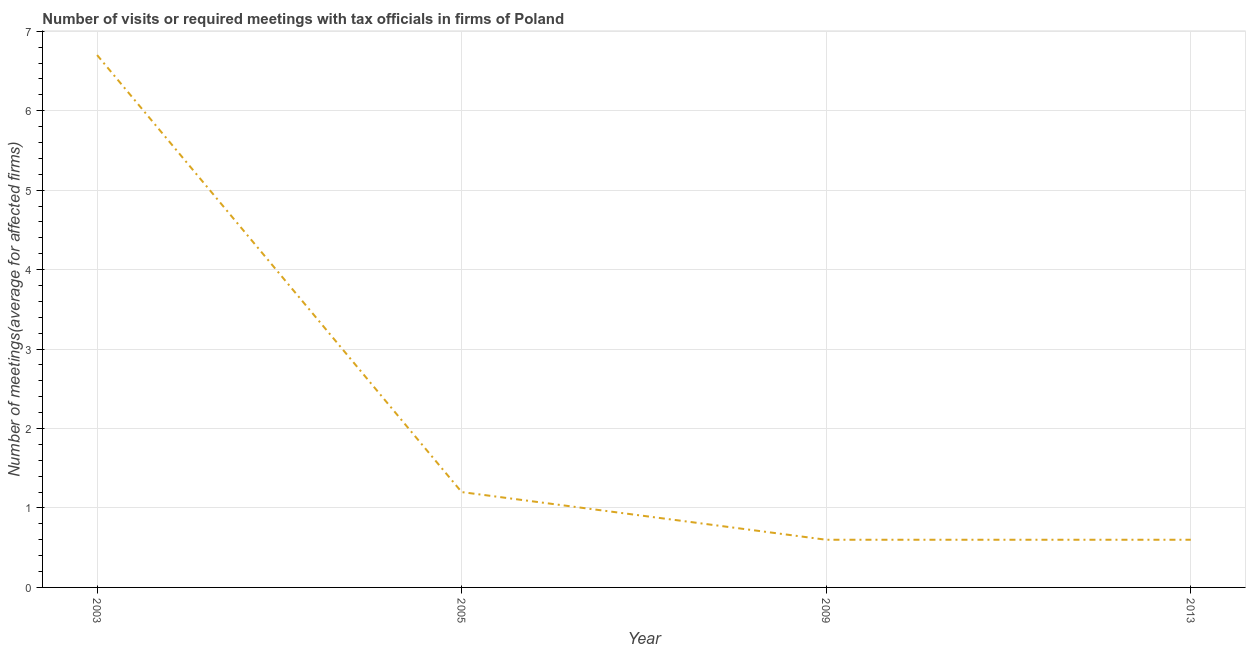What is the number of required meetings with tax officials in 2009?
Provide a succinct answer. 0.6. Across all years, what is the maximum number of required meetings with tax officials?
Make the answer very short. 6.7. Across all years, what is the minimum number of required meetings with tax officials?
Your answer should be compact. 0.6. What is the sum of the number of required meetings with tax officials?
Provide a succinct answer. 9.1. What is the average number of required meetings with tax officials per year?
Offer a very short reply. 2.27. What is the median number of required meetings with tax officials?
Offer a terse response. 0.9. Do a majority of the years between 2003 and 2005 (inclusive) have number of required meetings with tax officials greater than 5.4 ?
Offer a very short reply. No. What is the ratio of the number of required meetings with tax officials in 2003 to that in 2005?
Make the answer very short. 5.58. Is the difference between the number of required meetings with tax officials in 2003 and 2009 greater than the difference between any two years?
Your answer should be very brief. Yes. Is the sum of the number of required meetings with tax officials in 2009 and 2013 greater than the maximum number of required meetings with tax officials across all years?
Offer a very short reply. No. What is the difference between the highest and the lowest number of required meetings with tax officials?
Provide a short and direct response. 6.1. In how many years, is the number of required meetings with tax officials greater than the average number of required meetings with tax officials taken over all years?
Ensure brevity in your answer.  1. Does the number of required meetings with tax officials monotonically increase over the years?
Give a very brief answer. No. What is the title of the graph?
Offer a terse response. Number of visits or required meetings with tax officials in firms of Poland. What is the label or title of the Y-axis?
Provide a short and direct response. Number of meetings(average for affected firms). What is the Number of meetings(average for affected firms) in 2009?
Your answer should be very brief. 0.6. What is the difference between the Number of meetings(average for affected firms) in 2003 and 2005?
Give a very brief answer. 5.5. What is the difference between the Number of meetings(average for affected firms) in 2003 and 2009?
Your response must be concise. 6.1. What is the difference between the Number of meetings(average for affected firms) in 2003 and 2013?
Offer a terse response. 6.1. What is the difference between the Number of meetings(average for affected firms) in 2005 and 2009?
Ensure brevity in your answer.  0.6. What is the ratio of the Number of meetings(average for affected firms) in 2003 to that in 2005?
Give a very brief answer. 5.58. What is the ratio of the Number of meetings(average for affected firms) in 2003 to that in 2009?
Provide a short and direct response. 11.17. What is the ratio of the Number of meetings(average for affected firms) in 2003 to that in 2013?
Provide a succinct answer. 11.17. What is the ratio of the Number of meetings(average for affected firms) in 2005 to that in 2013?
Your answer should be very brief. 2. 